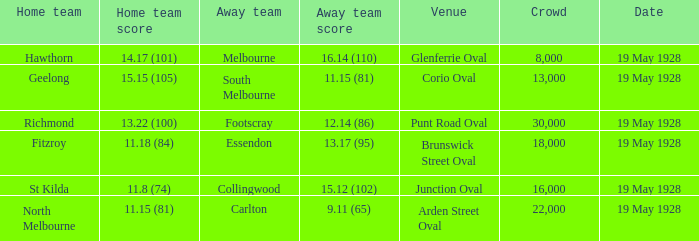What is the listed crowd when essendon is the away squad? 1.0. 